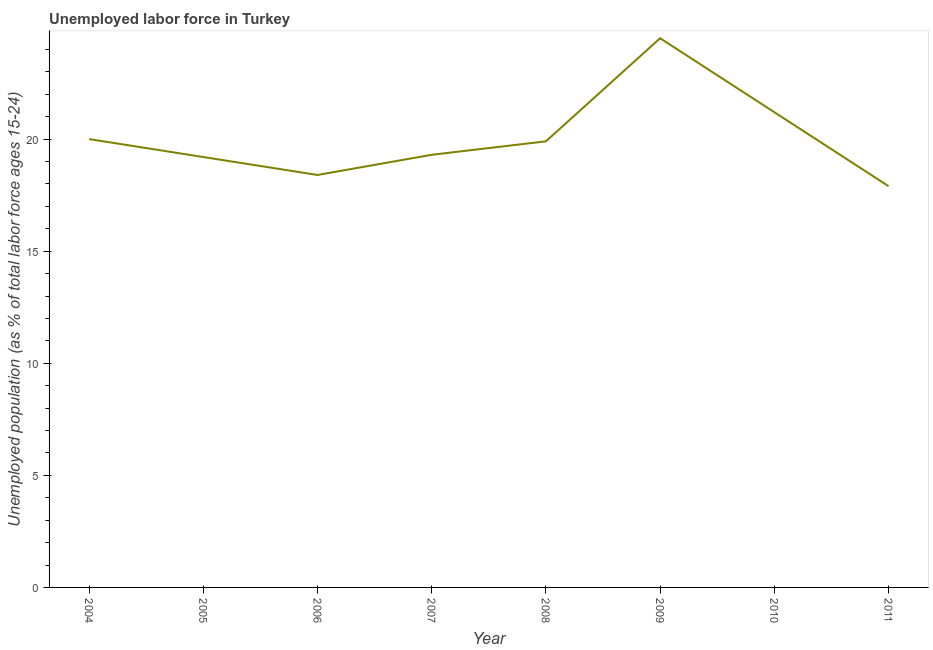What is the total unemployed youth population in 2007?
Keep it short and to the point. 19.3. Across all years, what is the minimum total unemployed youth population?
Give a very brief answer. 17.9. What is the sum of the total unemployed youth population?
Your response must be concise. 160.4. What is the difference between the total unemployed youth population in 2006 and 2007?
Provide a short and direct response. -0.9. What is the average total unemployed youth population per year?
Your response must be concise. 20.05. What is the median total unemployed youth population?
Your response must be concise. 19.6. In how many years, is the total unemployed youth population greater than 18 %?
Your answer should be compact. 7. Do a majority of the years between 2006 and 2011 (inclusive) have total unemployed youth population greater than 19 %?
Offer a terse response. Yes. What is the ratio of the total unemployed youth population in 2007 to that in 2011?
Provide a short and direct response. 1.08. What is the difference between the highest and the second highest total unemployed youth population?
Make the answer very short. 3.3. Is the sum of the total unemployed youth population in 2008 and 2009 greater than the maximum total unemployed youth population across all years?
Offer a very short reply. Yes. What is the difference between the highest and the lowest total unemployed youth population?
Provide a succinct answer. 6.6. In how many years, is the total unemployed youth population greater than the average total unemployed youth population taken over all years?
Your answer should be very brief. 2. Does the total unemployed youth population monotonically increase over the years?
Your answer should be very brief. No. How many lines are there?
Make the answer very short. 1. Are the values on the major ticks of Y-axis written in scientific E-notation?
Give a very brief answer. No. Does the graph contain any zero values?
Your response must be concise. No. What is the title of the graph?
Your response must be concise. Unemployed labor force in Turkey. What is the label or title of the Y-axis?
Offer a terse response. Unemployed population (as % of total labor force ages 15-24). What is the Unemployed population (as % of total labor force ages 15-24) in 2004?
Provide a short and direct response. 20. What is the Unemployed population (as % of total labor force ages 15-24) in 2005?
Offer a very short reply. 19.2. What is the Unemployed population (as % of total labor force ages 15-24) of 2006?
Make the answer very short. 18.4. What is the Unemployed population (as % of total labor force ages 15-24) in 2007?
Provide a short and direct response. 19.3. What is the Unemployed population (as % of total labor force ages 15-24) in 2008?
Your answer should be compact. 19.9. What is the Unemployed population (as % of total labor force ages 15-24) in 2009?
Ensure brevity in your answer.  24.5. What is the Unemployed population (as % of total labor force ages 15-24) in 2010?
Your answer should be very brief. 21.2. What is the Unemployed population (as % of total labor force ages 15-24) of 2011?
Provide a short and direct response. 17.9. What is the difference between the Unemployed population (as % of total labor force ages 15-24) in 2004 and 2007?
Your answer should be compact. 0.7. What is the difference between the Unemployed population (as % of total labor force ages 15-24) in 2004 and 2008?
Make the answer very short. 0.1. What is the difference between the Unemployed population (as % of total labor force ages 15-24) in 2005 and 2006?
Provide a succinct answer. 0.8. What is the difference between the Unemployed population (as % of total labor force ages 15-24) in 2005 and 2009?
Your answer should be compact. -5.3. What is the difference between the Unemployed population (as % of total labor force ages 15-24) in 2005 and 2010?
Make the answer very short. -2. What is the difference between the Unemployed population (as % of total labor force ages 15-24) in 2005 and 2011?
Provide a short and direct response. 1.3. What is the difference between the Unemployed population (as % of total labor force ages 15-24) in 2006 and 2007?
Offer a very short reply. -0.9. What is the difference between the Unemployed population (as % of total labor force ages 15-24) in 2006 and 2008?
Your answer should be very brief. -1.5. What is the difference between the Unemployed population (as % of total labor force ages 15-24) in 2007 and 2010?
Provide a short and direct response. -1.9. What is the difference between the Unemployed population (as % of total labor force ages 15-24) in 2008 and 2010?
Offer a terse response. -1.3. What is the difference between the Unemployed population (as % of total labor force ages 15-24) in 2009 and 2010?
Keep it short and to the point. 3.3. What is the difference between the Unemployed population (as % of total labor force ages 15-24) in 2010 and 2011?
Give a very brief answer. 3.3. What is the ratio of the Unemployed population (as % of total labor force ages 15-24) in 2004 to that in 2005?
Your answer should be compact. 1.04. What is the ratio of the Unemployed population (as % of total labor force ages 15-24) in 2004 to that in 2006?
Give a very brief answer. 1.09. What is the ratio of the Unemployed population (as % of total labor force ages 15-24) in 2004 to that in 2007?
Offer a terse response. 1.04. What is the ratio of the Unemployed population (as % of total labor force ages 15-24) in 2004 to that in 2008?
Your response must be concise. 1. What is the ratio of the Unemployed population (as % of total labor force ages 15-24) in 2004 to that in 2009?
Keep it short and to the point. 0.82. What is the ratio of the Unemployed population (as % of total labor force ages 15-24) in 2004 to that in 2010?
Your response must be concise. 0.94. What is the ratio of the Unemployed population (as % of total labor force ages 15-24) in 2004 to that in 2011?
Keep it short and to the point. 1.12. What is the ratio of the Unemployed population (as % of total labor force ages 15-24) in 2005 to that in 2006?
Provide a succinct answer. 1.04. What is the ratio of the Unemployed population (as % of total labor force ages 15-24) in 2005 to that in 2007?
Ensure brevity in your answer.  0.99. What is the ratio of the Unemployed population (as % of total labor force ages 15-24) in 2005 to that in 2008?
Keep it short and to the point. 0.96. What is the ratio of the Unemployed population (as % of total labor force ages 15-24) in 2005 to that in 2009?
Ensure brevity in your answer.  0.78. What is the ratio of the Unemployed population (as % of total labor force ages 15-24) in 2005 to that in 2010?
Keep it short and to the point. 0.91. What is the ratio of the Unemployed population (as % of total labor force ages 15-24) in 2005 to that in 2011?
Give a very brief answer. 1.07. What is the ratio of the Unemployed population (as % of total labor force ages 15-24) in 2006 to that in 2007?
Provide a short and direct response. 0.95. What is the ratio of the Unemployed population (as % of total labor force ages 15-24) in 2006 to that in 2008?
Your answer should be very brief. 0.93. What is the ratio of the Unemployed population (as % of total labor force ages 15-24) in 2006 to that in 2009?
Your answer should be compact. 0.75. What is the ratio of the Unemployed population (as % of total labor force ages 15-24) in 2006 to that in 2010?
Give a very brief answer. 0.87. What is the ratio of the Unemployed population (as % of total labor force ages 15-24) in 2006 to that in 2011?
Provide a succinct answer. 1.03. What is the ratio of the Unemployed population (as % of total labor force ages 15-24) in 2007 to that in 2009?
Your answer should be compact. 0.79. What is the ratio of the Unemployed population (as % of total labor force ages 15-24) in 2007 to that in 2010?
Ensure brevity in your answer.  0.91. What is the ratio of the Unemployed population (as % of total labor force ages 15-24) in 2007 to that in 2011?
Offer a very short reply. 1.08. What is the ratio of the Unemployed population (as % of total labor force ages 15-24) in 2008 to that in 2009?
Make the answer very short. 0.81. What is the ratio of the Unemployed population (as % of total labor force ages 15-24) in 2008 to that in 2010?
Make the answer very short. 0.94. What is the ratio of the Unemployed population (as % of total labor force ages 15-24) in 2008 to that in 2011?
Keep it short and to the point. 1.11. What is the ratio of the Unemployed population (as % of total labor force ages 15-24) in 2009 to that in 2010?
Provide a succinct answer. 1.16. What is the ratio of the Unemployed population (as % of total labor force ages 15-24) in 2009 to that in 2011?
Your response must be concise. 1.37. What is the ratio of the Unemployed population (as % of total labor force ages 15-24) in 2010 to that in 2011?
Ensure brevity in your answer.  1.18. 